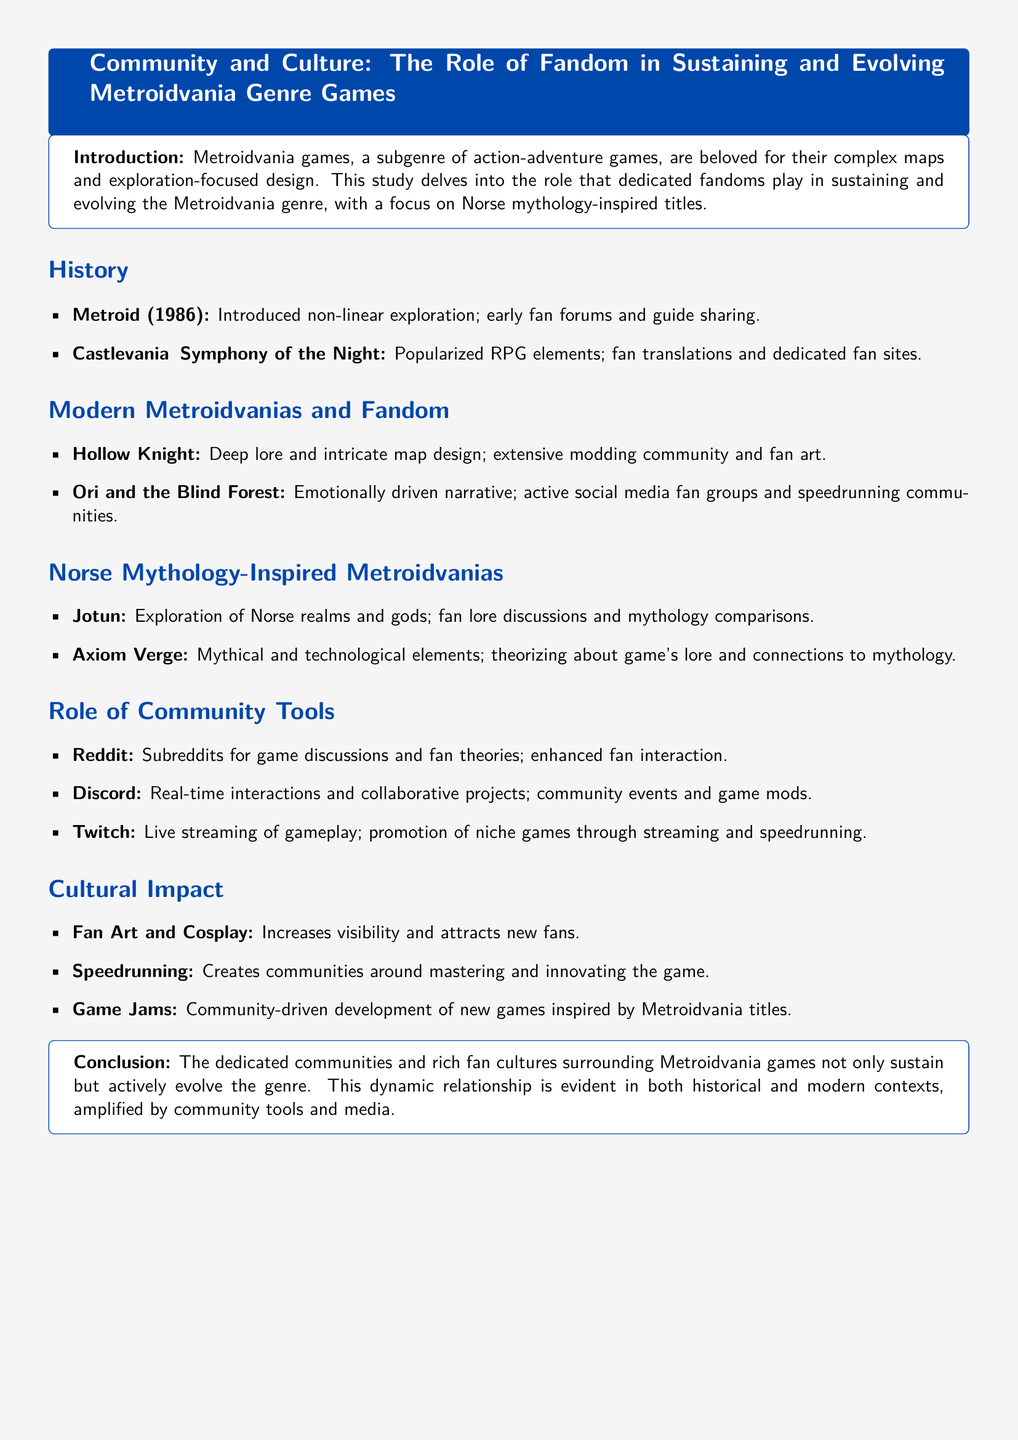What is the title of the case study? The title of the case study is provided in the document header, highlighting the focus on fandom and the Metroidvania genre.
Answer: Community and Culture: The Role of Fandom in Sustaining and Evolving Metroidvania Genre Games In what year was Metroid released? The document lists the year of the original Metroid game in the history section, indicating its significance in the genre.
Answer: 1986 Which game popularized RPG elements? The document specifically mentions Castlevania: Symphony of the Night for its influence on adding RPG elements to the genre.
Answer: Castlevania: Symphony of the Night Name one Norse mythology-inspired Metroidvania mentioned. The section on Norse mythology-inspired Metroidvanias lists specific games, one of which can be chosen as an example.
Answer: Jotun What community tool is mentioned alongside Reddit? The document identifies several community tools used by fans, mentioning them in relation to their role in fostering interaction.
Answer: Discord What is a cultural impact of fandom highlighted in the document? The document discusses various cultural impacts associated with fandoms, one of which pertains directly to artistic expression.
Answer: Fan Art and Cosplay Which modern Metroidvania features an emotionally-driven narrative? Among the games discussed in the modern Metroidvania section, one is noted for its focus on narrative elements.
Answer: Ori and the Blind Forest What activity creates communities around mastering the game? The document describes a specific activity that fosters community engagement in a competitive manner.
Answer: Speedrunning What does the conclusion emphasize about fan cultures? The conclusion summarizes the significance of communities in the evolution of the Metroidvania genre.
Answer: Actively evolve the genre 